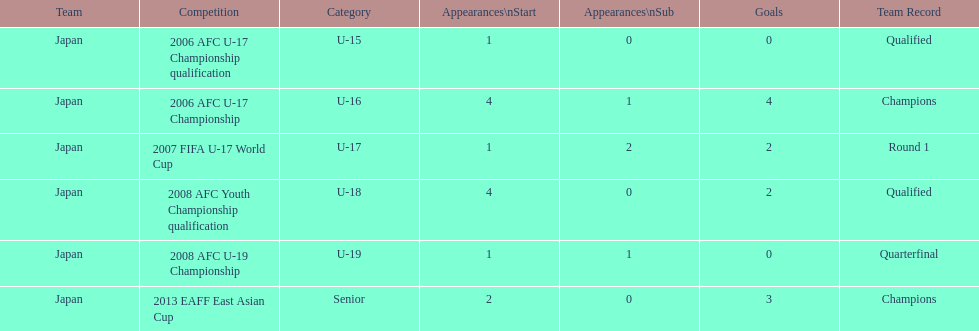Which tournament featured the highest amount of starts and goals? 2006 AFC U-17 Championship. 